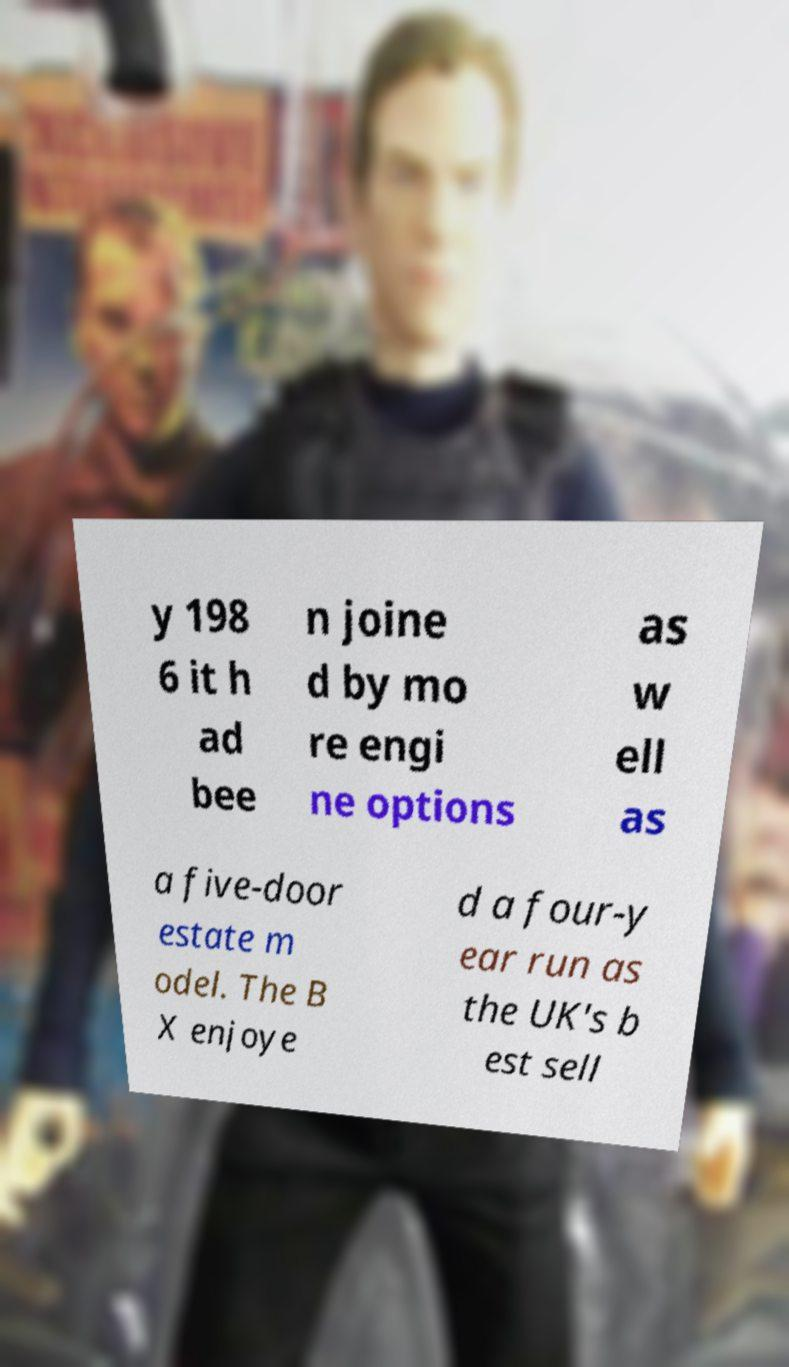Please identify and transcribe the text found in this image. y 198 6 it h ad bee n joine d by mo re engi ne options as w ell as a five-door estate m odel. The B X enjoye d a four-y ear run as the UK's b est sell 